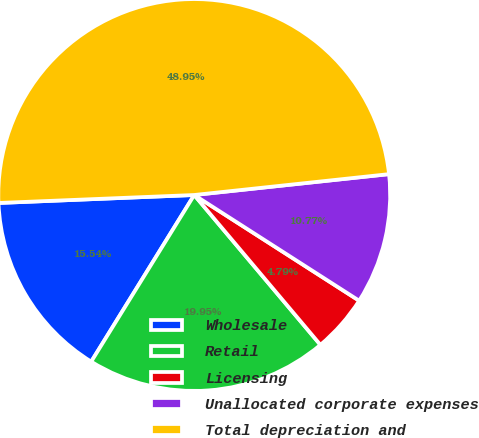Convert chart to OTSL. <chart><loc_0><loc_0><loc_500><loc_500><pie_chart><fcel>Wholesale<fcel>Retail<fcel>Licensing<fcel>Unallocated corporate expenses<fcel>Total depreciation and<nl><fcel>15.54%<fcel>19.95%<fcel>4.79%<fcel>10.77%<fcel>48.95%<nl></chart> 